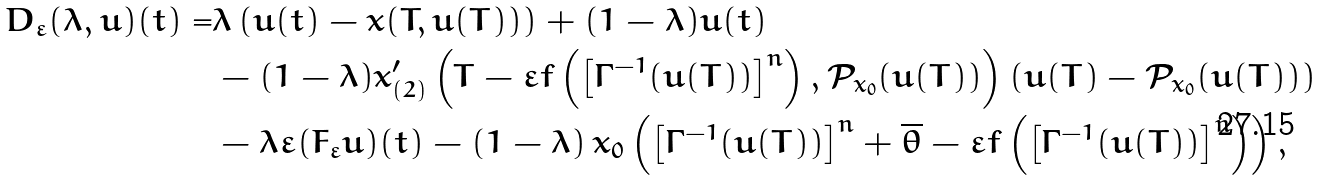Convert formula to latex. <formula><loc_0><loc_0><loc_500><loc_500>D _ { \varepsilon } ( \lambda , u ) ( t ) = & \lambda \left ( u ( t ) - x ( T , u ( T ) ) \right ) + ( 1 - \lambda ) u ( t ) \\ & - ( 1 - \lambda ) x ^ { \prime } _ { ( 2 ) } \left ( T - \varepsilon f \left ( \left [ \Gamma ^ { - 1 } ( u ( T ) ) \right ] ^ { n } \right ) , \mathcal { P } _ { x _ { 0 } } ( u ( T ) ) \right ) ( u ( T ) - \mathcal { P } _ { x _ { 0 } } ( u ( T ) ) ) \\ & - \lambda \varepsilon ( { F _ { \varepsilon } } u ) ( t ) - ( 1 - \lambda ) \, x _ { 0 } \left ( \left [ \Gamma ^ { - 1 } ( u ( T ) ) \right ] ^ { n } + \overline { \theta } - \varepsilon f \left ( \left [ \Gamma ^ { - 1 } ( u ( T ) ) \right ] ^ { n } \right ) \right ) ,</formula> 